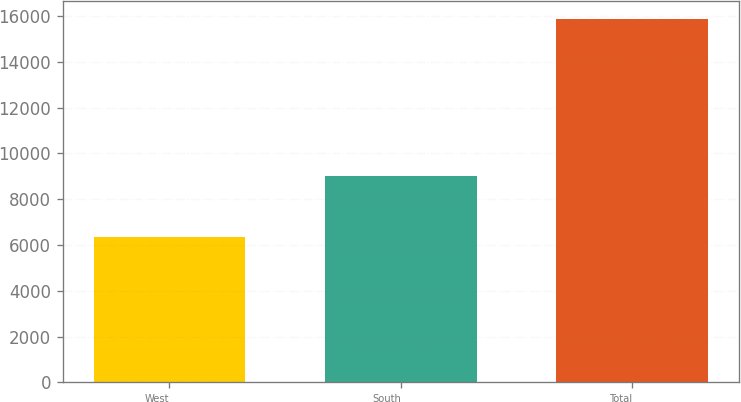<chart> <loc_0><loc_0><loc_500><loc_500><bar_chart><fcel>West<fcel>South<fcel>Total<nl><fcel>6359<fcel>8996<fcel>15858<nl></chart> 